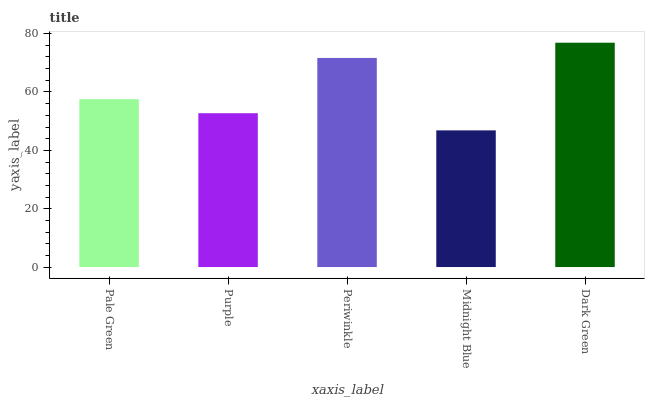Is Purple the minimum?
Answer yes or no. No. Is Purple the maximum?
Answer yes or no. No. Is Pale Green greater than Purple?
Answer yes or no. Yes. Is Purple less than Pale Green?
Answer yes or no. Yes. Is Purple greater than Pale Green?
Answer yes or no. No. Is Pale Green less than Purple?
Answer yes or no. No. Is Pale Green the high median?
Answer yes or no. Yes. Is Pale Green the low median?
Answer yes or no. Yes. Is Periwinkle the high median?
Answer yes or no. No. Is Periwinkle the low median?
Answer yes or no. No. 